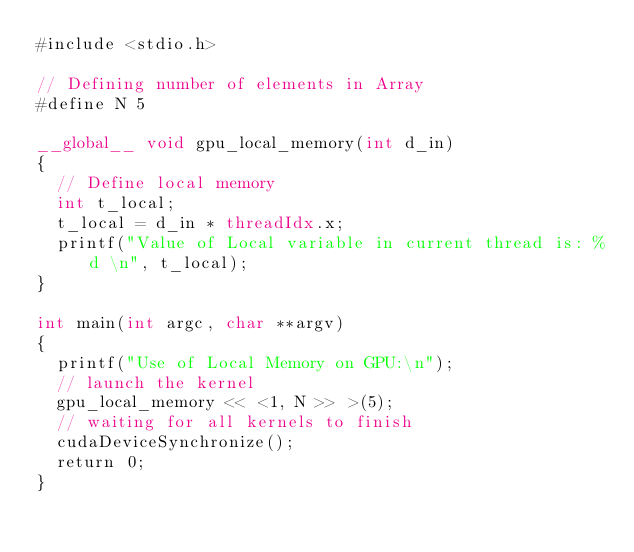<code> <loc_0><loc_0><loc_500><loc_500><_Cuda_>#include <stdio.h>

// Defining number of elements in Array
#define N 5

__global__ void gpu_local_memory(int d_in)
{
	// Define local memory
	int t_local;
	t_local = d_in * threadIdx.x;
	printf("Value of Local variable in current thread is: %d \n", t_local);
}

int main(int argc, char **argv)
{
	printf("Use of Local Memory on GPU:\n");
	// launch the kernel
	gpu_local_memory << <1, N >> >(5);  
	// waiting for all kernels to finish
	cudaDeviceSynchronize();
	return 0;
}
</code> 